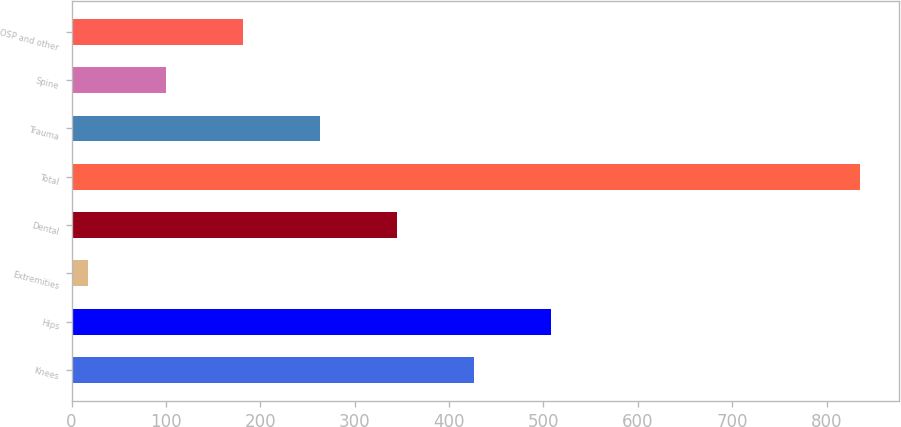<chart> <loc_0><loc_0><loc_500><loc_500><bar_chart><fcel>Knees<fcel>Hips<fcel>Extremities<fcel>Dental<fcel>Total<fcel>Trauma<fcel>Spine<fcel>OSP and other<nl><fcel>426.5<fcel>508.22<fcel>17.9<fcel>344.78<fcel>835.1<fcel>263.06<fcel>99.62<fcel>181.34<nl></chart> 